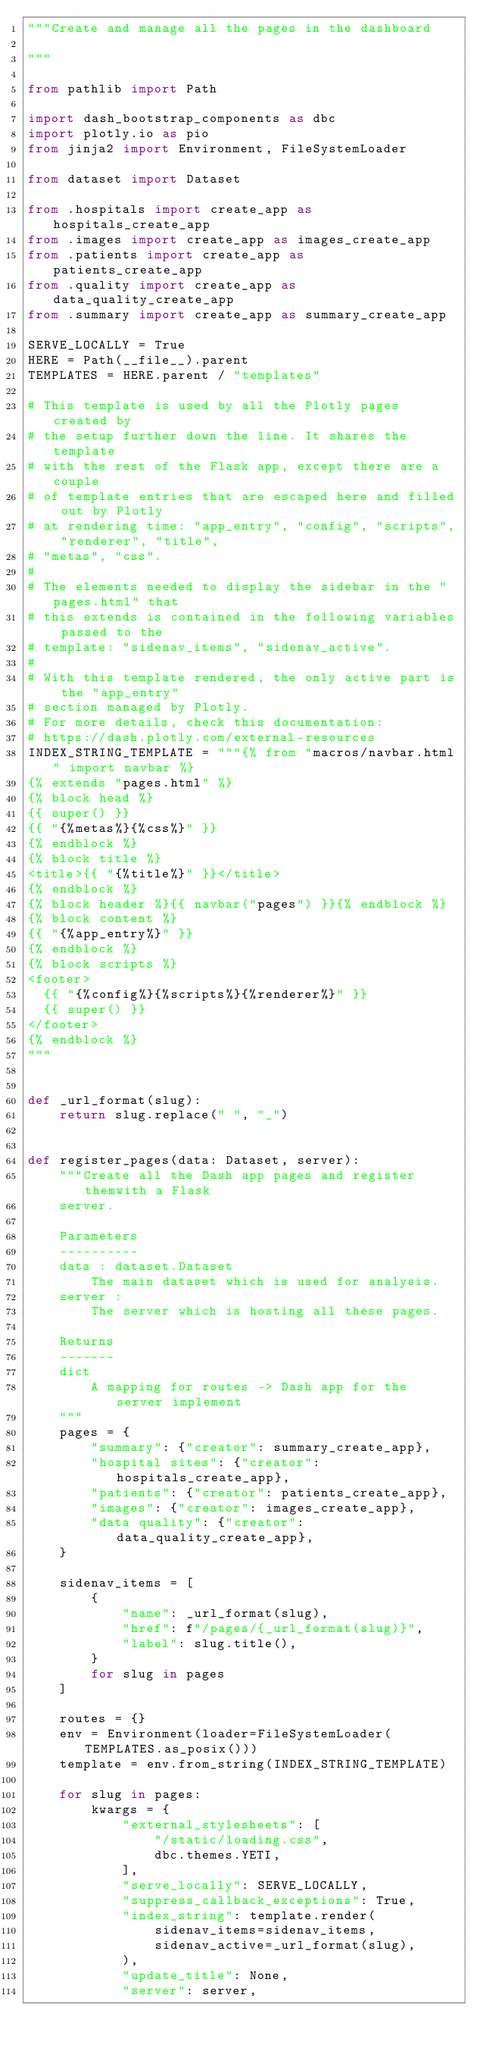<code> <loc_0><loc_0><loc_500><loc_500><_Python_>"""Create and manage all the pages in the dashboard

"""

from pathlib import Path

import dash_bootstrap_components as dbc
import plotly.io as pio
from jinja2 import Environment, FileSystemLoader

from dataset import Dataset

from .hospitals import create_app as hospitals_create_app
from .images import create_app as images_create_app
from .patients import create_app as patients_create_app
from .quality import create_app as data_quality_create_app
from .summary import create_app as summary_create_app

SERVE_LOCALLY = True
HERE = Path(__file__).parent
TEMPLATES = HERE.parent / "templates"

# This template is used by all the Plotly pages created by
# the setup further down the line. It shares the template
# with the rest of the Flask app, except there are a couple
# of template entries that are escaped here and filled out by Plotly
# at rendering time: "app_entry", "config", "scripts", "renderer", "title",
# "metas", "css".
#
# The elements needed to display the sidebar in the "pages.html" that
# this extends is contained in the following variables passed to the
# template: "sidenav_items", "sidenav_active".
#
# With this template rendered, the only active part is the "app_entry"
# section managed by Plotly.
# For more details, check this documentation:
# https://dash.plotly.com/external-resources
INDEX_STRING_TEMPLATE = """{% from "macros/navbar.html" import navbar %}
{% extends "pages.html" %}
{% block head %}
{{ super() }}
{{ "{%metas%}{%css%}" }}
{% endblock %}
{% block title %}
<title>{{ "{%title%}" }}</title>
{% endblock %}
{% block header %}{{ navbar("pages") }}{% endblock %}
{% block content %}
{{ "{%app_entry%}" }}
{% endblock %}
{% block scripts %}
<footer>
  {{ "{%config%}{%scripts%}{%renderer%}" }}
  {{ super() }}
</footer>
{% endblock %}
"""


def _url_format(slug):
    return slug.replace(" ", "_")


def register_pages(data: Dataset, server):
    """Create all the Dash app pages and register themwith a Flask
    server.

    Parameters
    ----------
    data : dataset.Dataset
        The main dataset which is used for analysis.
    server :
        The server which is hosting all these pages.

    Returns
    -------
    dict
        A mapping for routes -> Dash app for the server implement
    """
    pages = {
        "summary": {"creator": summary_create_app},
        "hospital sites": {"creator": hospitals_create_app},
        "patients": {"creator": patients_create_app},
        "images": {"creator": images_create_app},
        "data quality": {"creator": data_quality_create_app},
    }

    sidenav_items = [
        {
            "name": _url_format(slug),
            "href": f"/pages/{_url_format(slug)}",
            "label": slug.title(),
        }
        for slug in pages
    ]

    routes = {}
    env = Environment(loader=FileSystemLoader(TEMPLATES.as_posix()))
    template = env.from_string(INDEX_STRING_TEMPLATE)

    for slug in pages:
        kwargs = {
            "external_stylesheets": [
                "/static/loading.css",
                dbc.themes.YETI,
            ],
            "serve_locally": SERVE_LOCALLY,
            "suppress_callback_exceptions": True,
            "index_string": template.render(
                sidenav_items=sidenav_items,
                sidenav_active=_url_format(slug),
            ),
            "update_title": None,
            "server": server,</code> 